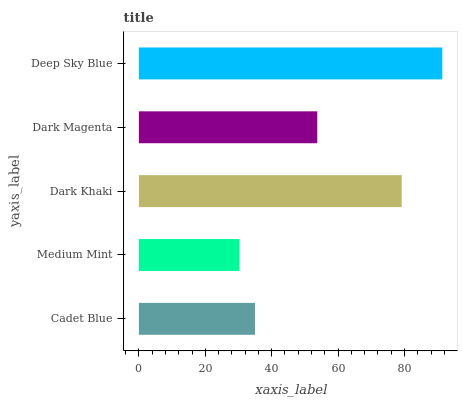Is Medium Mint the minimum?
Answer yes or no. Yes. Is Deep Sky Blue the maximum?
Answer yes or no. Yes. Is Dark Khaki the minimum?
Answer yes or no. No. Is Dark Khaki the maximum?
Answer yes or no. No. Is Dark Khaki greater than Medium Mint?
Answer yes or no. Yes. Is Medium Mint less than Dark Khaki?
Answer yes or no. Yes. Is Medium Mint greater than Dark Khaki?
Answer yes or no. No. Is Dark Khaki less than Medium Mint?
Answer yes or no. No. Is Dark Magenta the high median?
Answer yes or no. Yes. Is Dark Magenta the low median?
Answer yes or no. Yes. Is Cadet Blue the high median?
Answer yes or no. No. Is Medium Mint the low median?
Answer yes or no. No. 